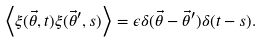Convert formula to latex. <formula><loc_0><loc_0><loc_500><loc_500>\left < \xi ( \vec { \theta } , t ) \xi ( \vec { \theta } ^ { \prime } , s ) \right > = \epsilon \delta ( \vec { \theta } - \vec { \theta } ^ { \prime } ) \delta ( t - s ) .</formula> 